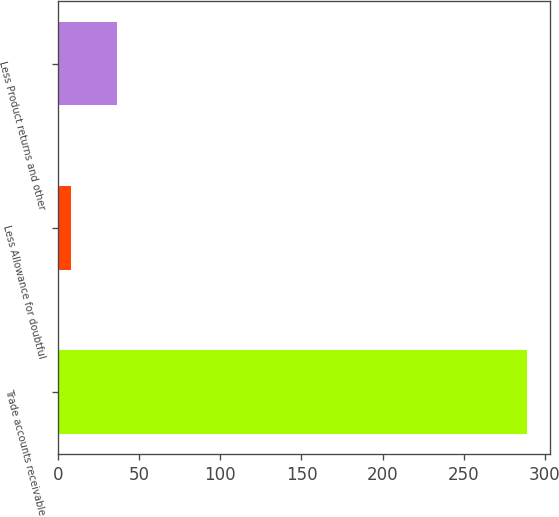<chart> <loc_0><loc_0><loc_500><loc_500><bar_chart><fcel>Trade accounts receivable<fcel>Less Allowance for doubtful<fcel>Less Product returns and other<nl><fcel>288.7<fcel>8.2<fcel>36.25<nl></chart> 